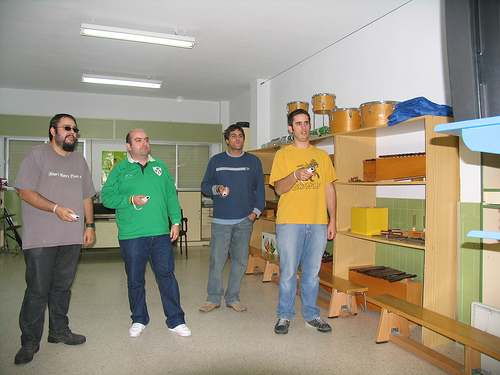<image>Is the door behind the man open or closed? I am not sure if the door behind the man is open or closed. Is the door behind the man open or closed? I don't know if the door behind the man is open or closed. 